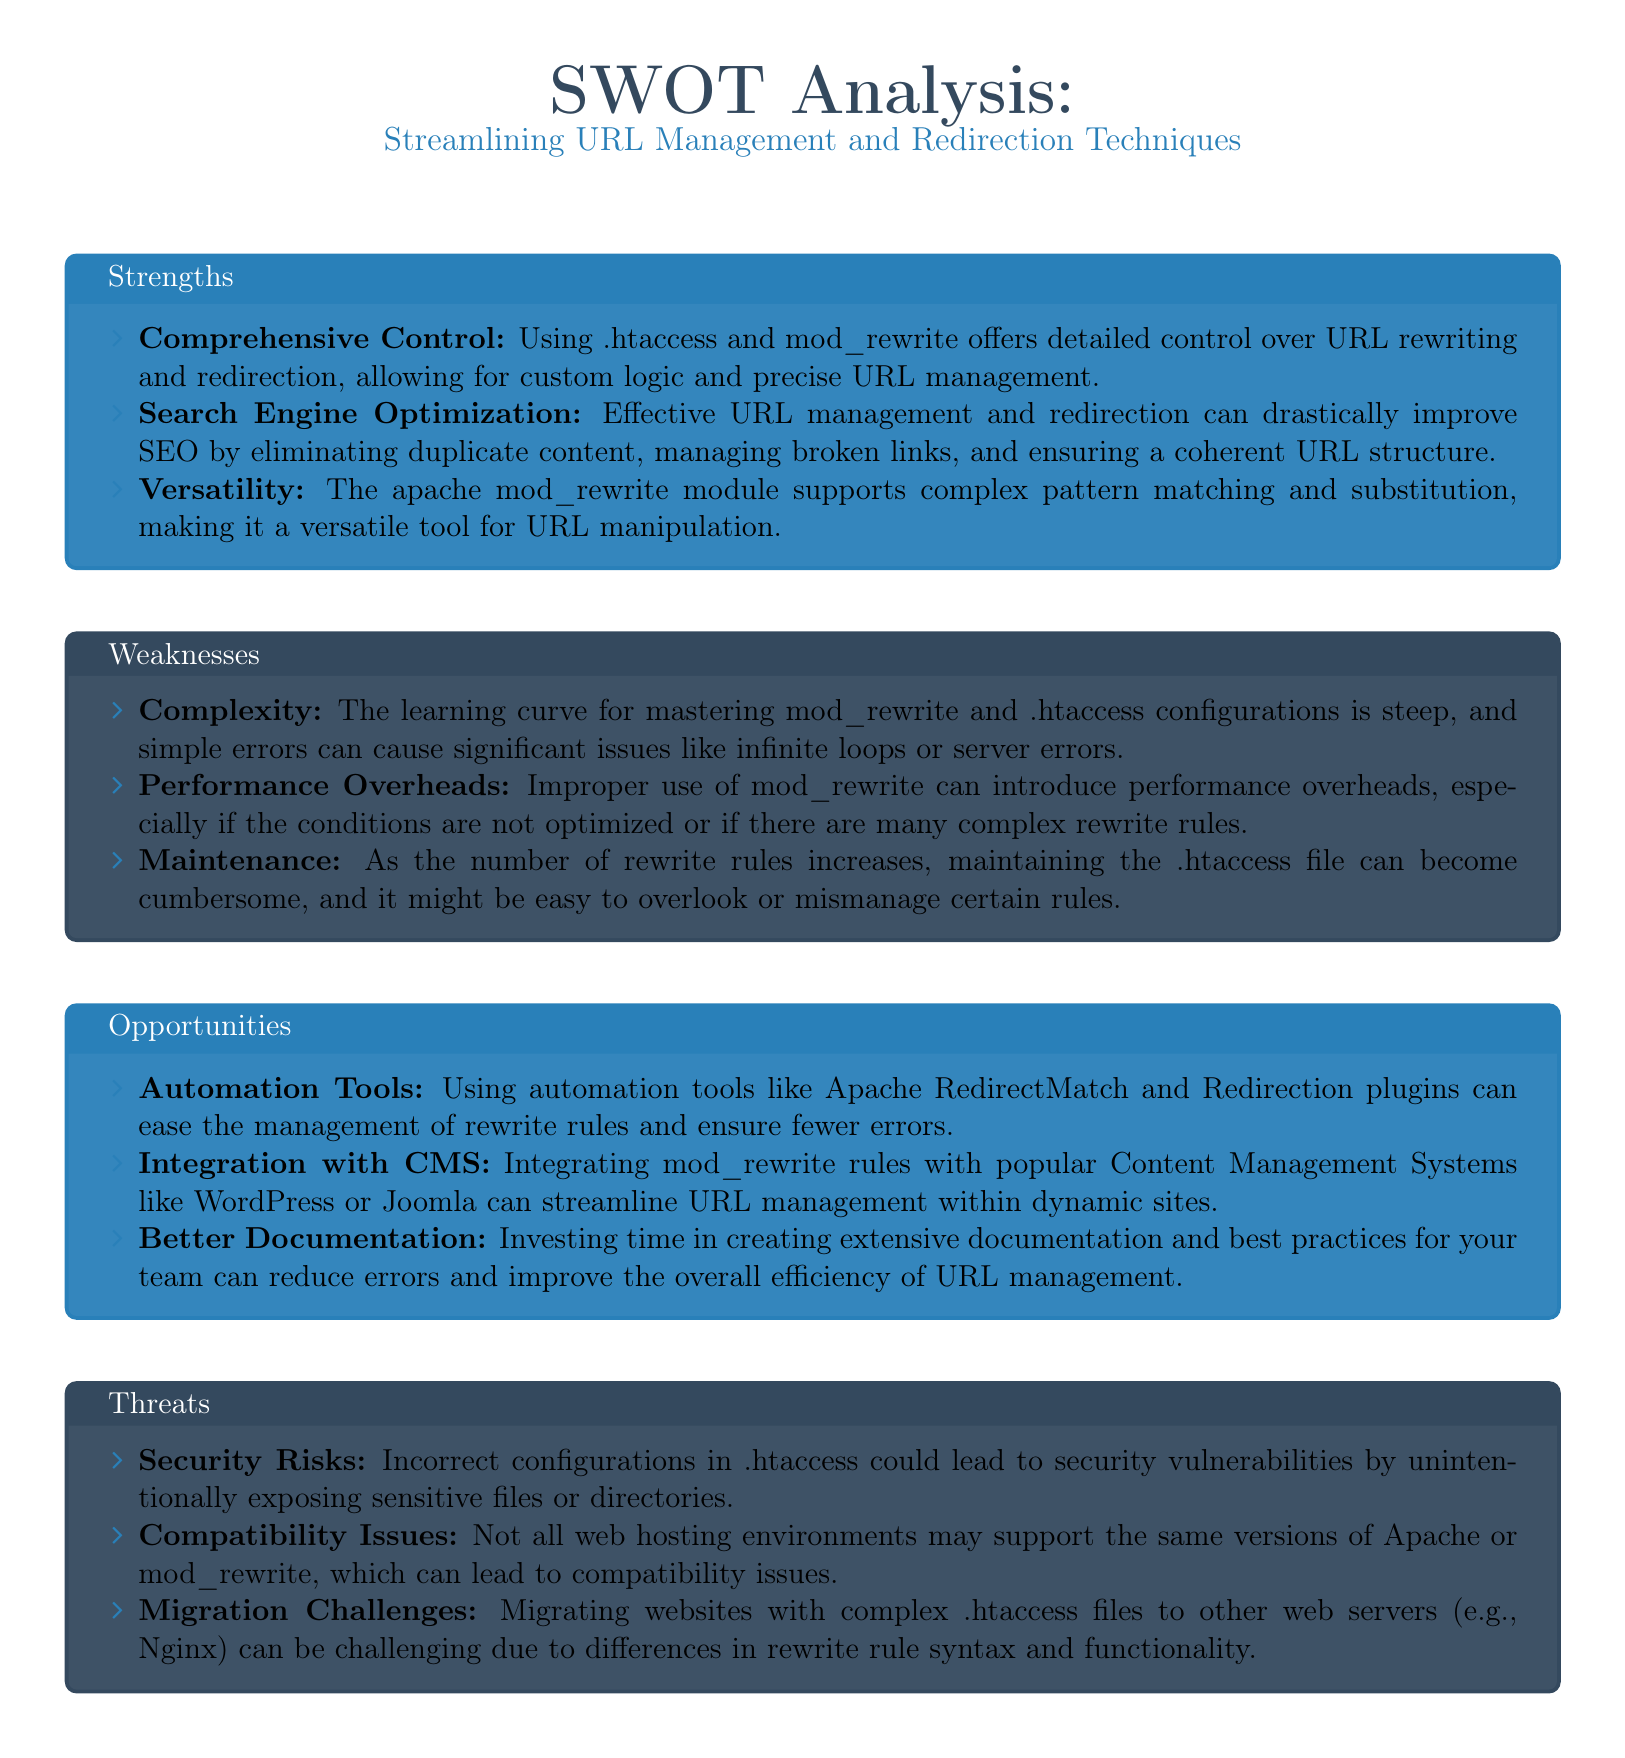What are the strengths listed in the SWOT analysis? The strengths are detailed under the "Strengths" section in the SWOT analysis, which includes Comprehensive Control, Search Engine Optimization, and Versatility.
Answer: Comprehensive Control, Search Engine Optimization, Versatility What is one weakness of using .htaccess and mod_rewrite? The weaknesses are listed in the "Weaknesses" section of the SWOT analysis. One of the weaknesses is Complexity.
Answer: Complexity What opportunity involves automation tools? The opportunities section mentions the use of automation tools like Apache RedirectMatch.
Answer: Automation Tools What is a threat related to security? The threats section discusses risks, one of which is Security Risks.
Answer: Security Risks How many main categories are in the SWOT analysis? The document is structured into four main categories: Strengths, Weaknesses, Opportunities, and Threats.
Answer: Four Which opportunity focuses on Content Management Systems? The opportunity that discusses integration with Content Management Systems can be found in the Opportunities section.
Answer: Integration with CMS What performance issue is mentioned as a weakness? The weaknesses section includes Performance Overheads as a specific issue.
Answer: Performance Overheads What is a noted challenge when migrating .htaccess files? The Threats section indicates that Migration Challenges can be significant when dealing with .htaccess files.
Answer: Migration Challenges 